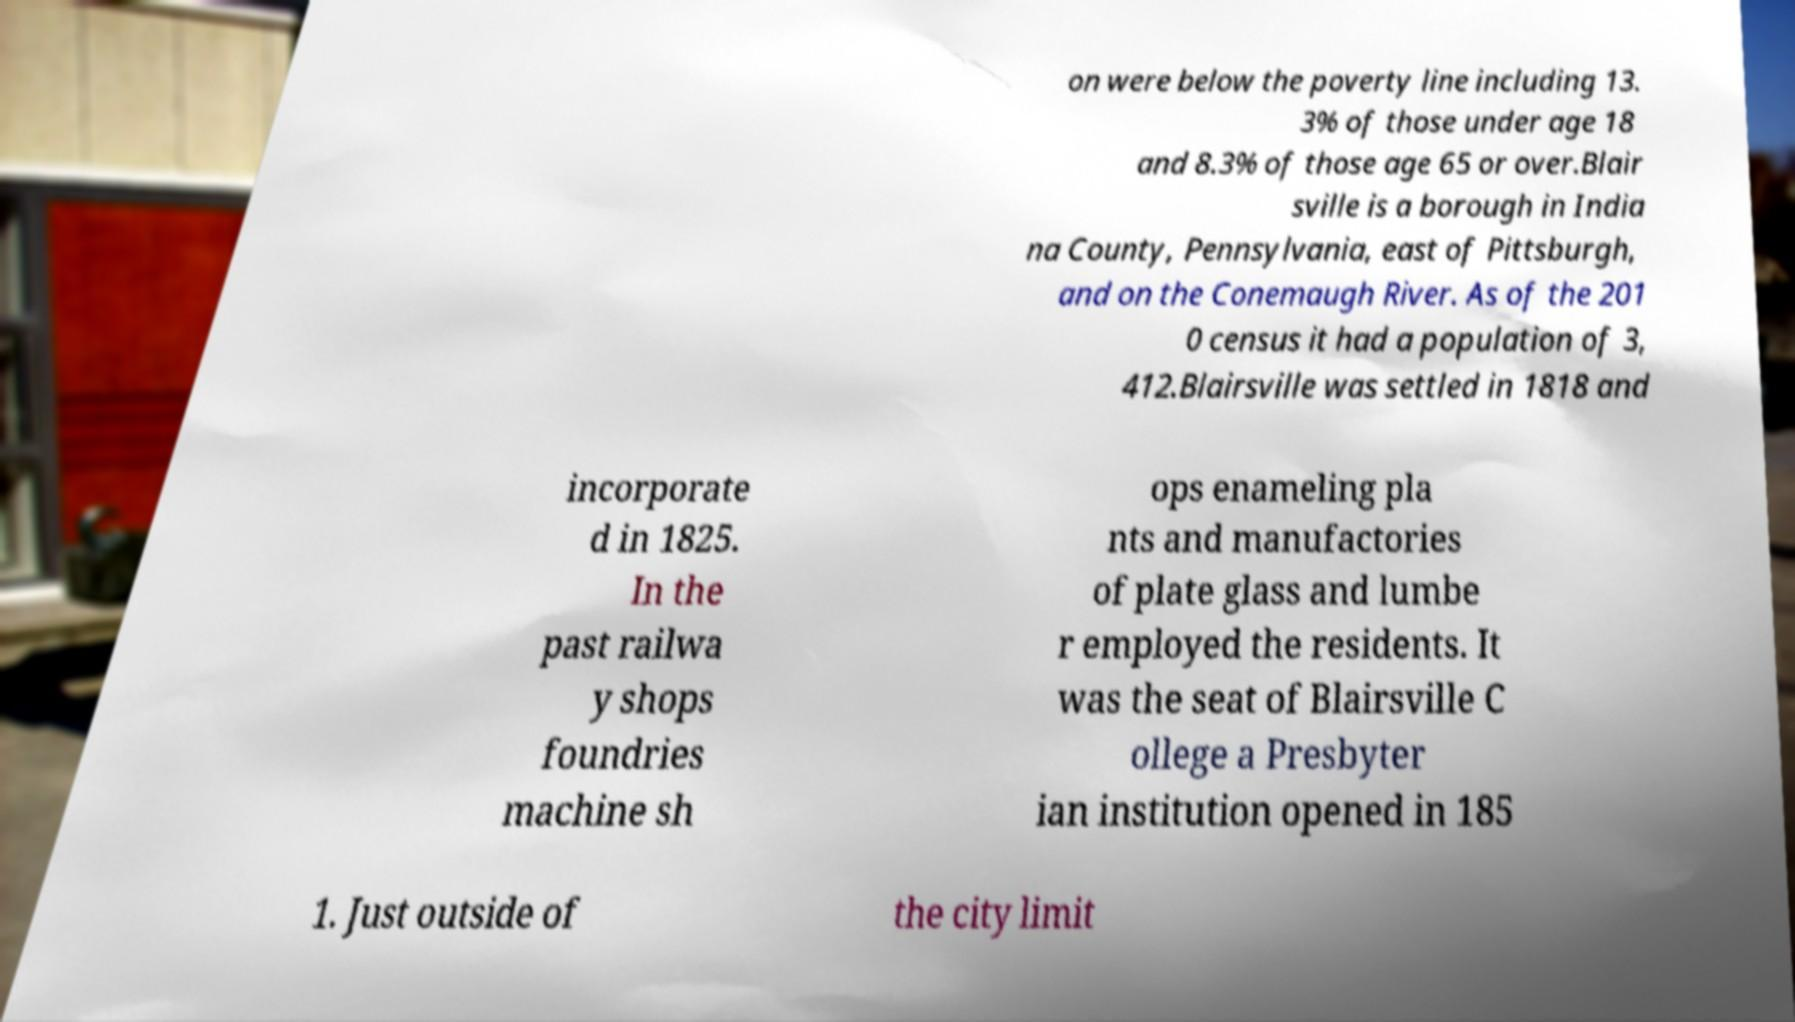Please read and relay the text visible in this image. What does it say? on were below the poverty line including 13. 3% of those under age 18 and 8.3% of those age 65 or over.Blair sville is a borough in India na County, Pennsylvania, east of Pittsburgh, and on the Conemaugh River. As of the 201 0 census it had a population of 3, 412.Blairsville was settled in 1818 and incorporate d in 1825. In the past railwa y shops foundries machine sh ops enameling pla nts and manufactories of plate glass and lumbe r employed the residents. It was the seat of Blairsville C ollege a Presbyter ian institution opened in 185 1. Just outside of the city limit 